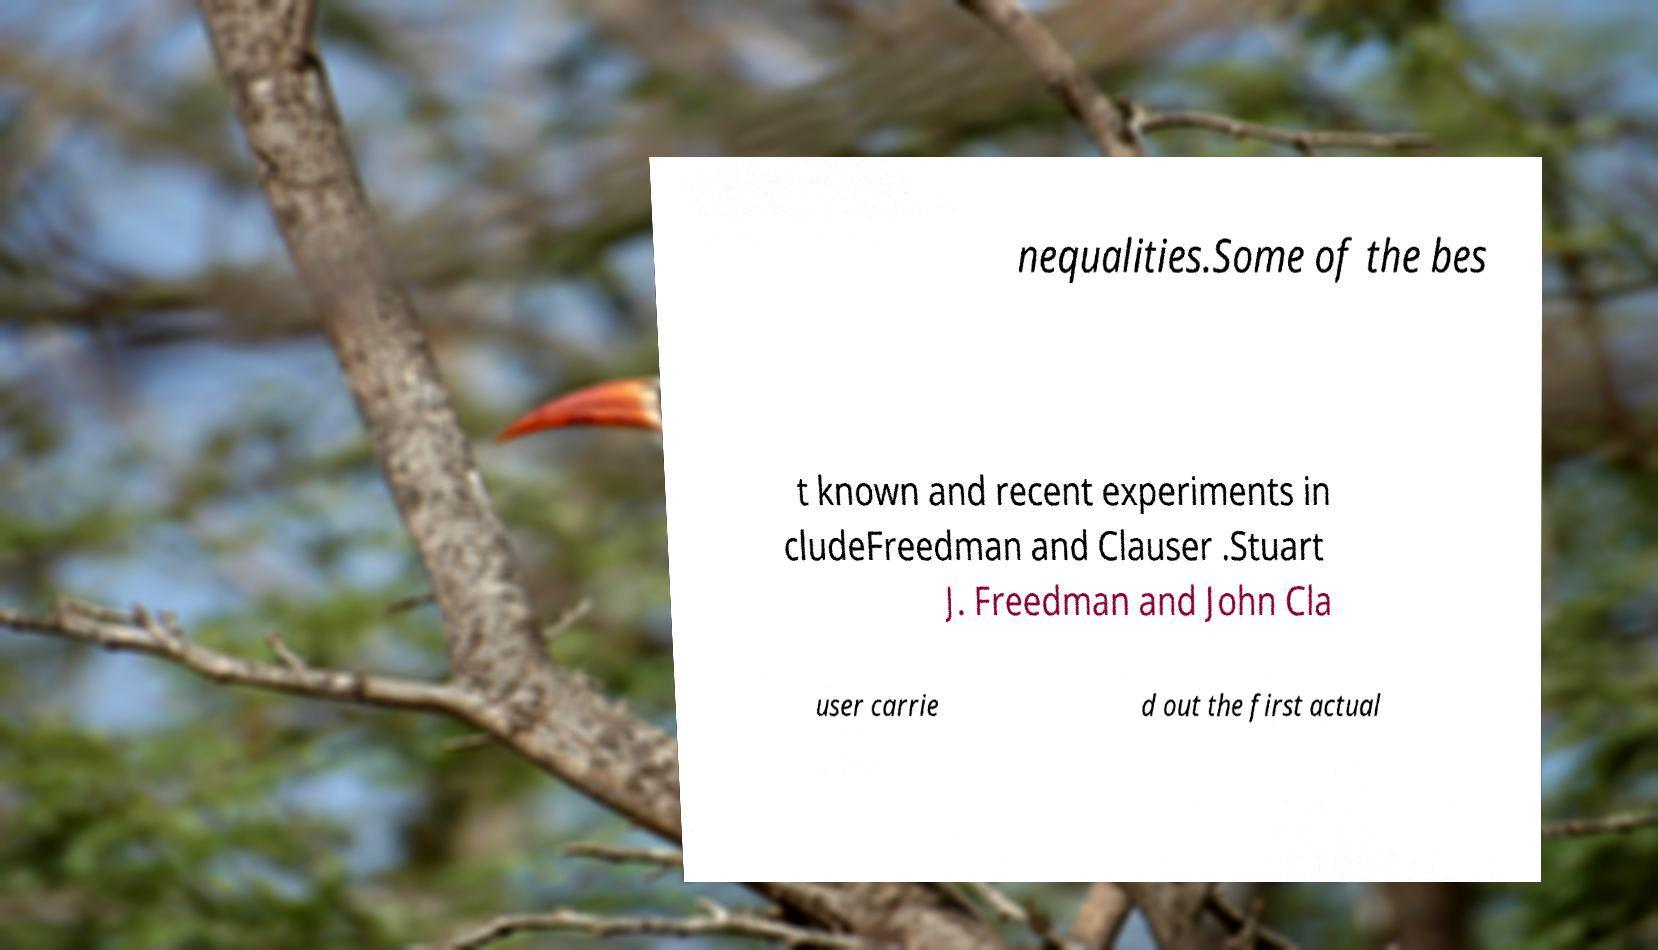Please identify and transcribe the text found in this image. nequalities.Some of the bes t known and recent experiments in cludeFreedman and Clauser .Stuart J. Freedman and John Cla user carrie d out the first actual 